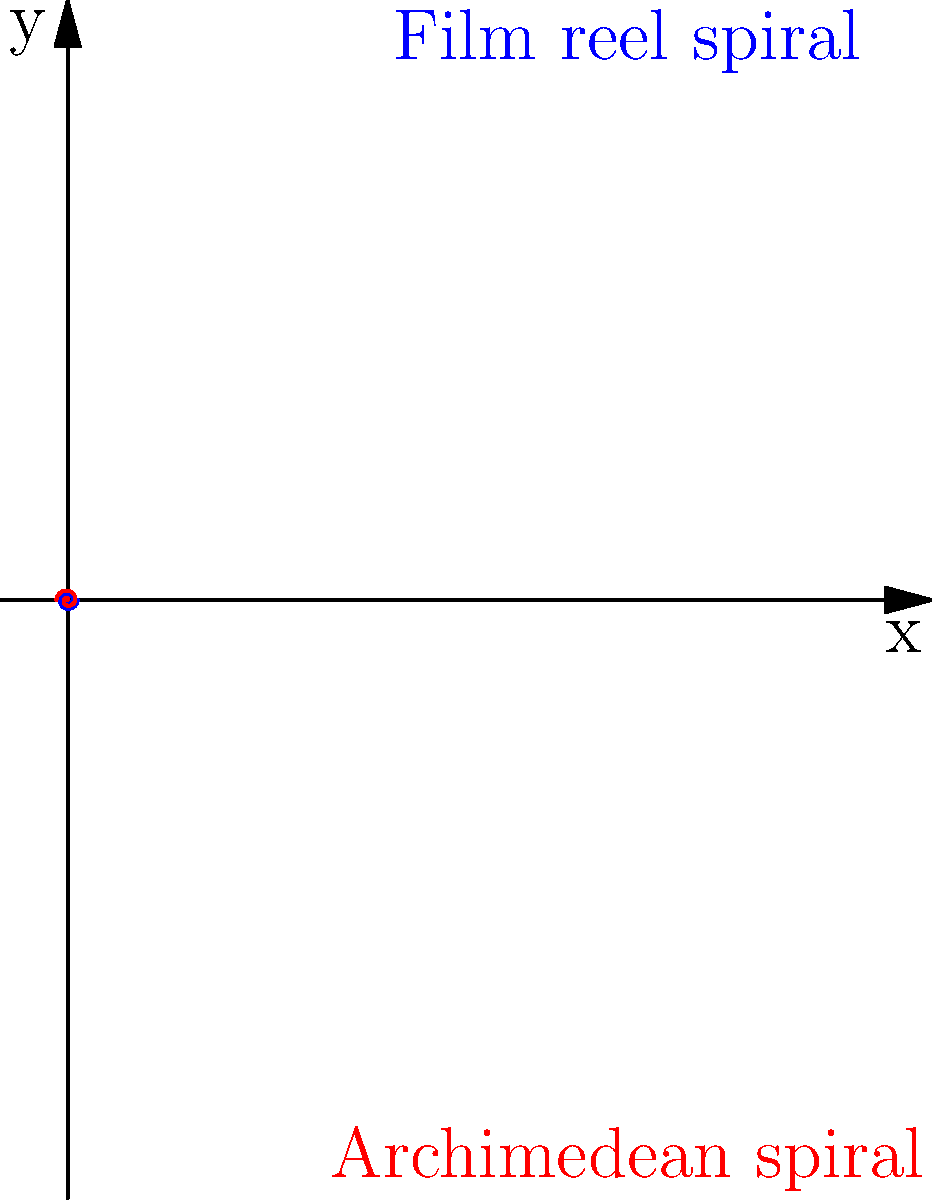In the context of early 20th century film technology, how does the spiral shape of a film reel compare to an Archimedean spiral when represented in polar coordinates? Consider the equation $r = a\theta$ for an Archimedean spiral, where $a$ is a constant and $\theta$ is the polar angle. To compare the spiral shape of a film reel to an Archimedean spiral in polar coordinates, we need to consider the following steps:

1. Archimedean spiral equation: $r = a\theta$, where $a$ is a constant and $\theta$ is the polar angle.

2. Film reel spiral characteristics:
   - Starts from the center and winds outward
   - Maintains a constant distance between each turn
   - The radius increases linearly with the angle of rotation

3. Comparing the properties:
   - Both spirals start from the center (origin in polar coordinates)
   - Both have a linear relationship between radius and angle
   - The constant $a$ in the Archimedean spiral equation determines the distance between turns, similar to the spacing of film on a reel

4. Key difference:
   - Film reels have a finite number of turns, while an Archimedean spiral theoretically continues indefinitely

5. In the context of early 20th century cinema:
   - The spiral shape of film reels was crucial for efficient storage and playback of motion pictures
   - The Archimedean spiral model closely approximates the actual shape of film wound on a reel

6. Mathematical representation:
   - For a film reel, we can use the same equation $r = a\theta$, but with a limited range for $\theta$
   - The value of $a$ would be determined by the film width and reel dimensions

Therefore, the spiral shape of a film reel closely resembles an Archimedean spiral in polar coordinates, with the main difference being the finite nature of the film reel spiral.
Answer: Film reel spirals closely resemble Archimedean spirals ($r = a\theta$) but are finite in length. 